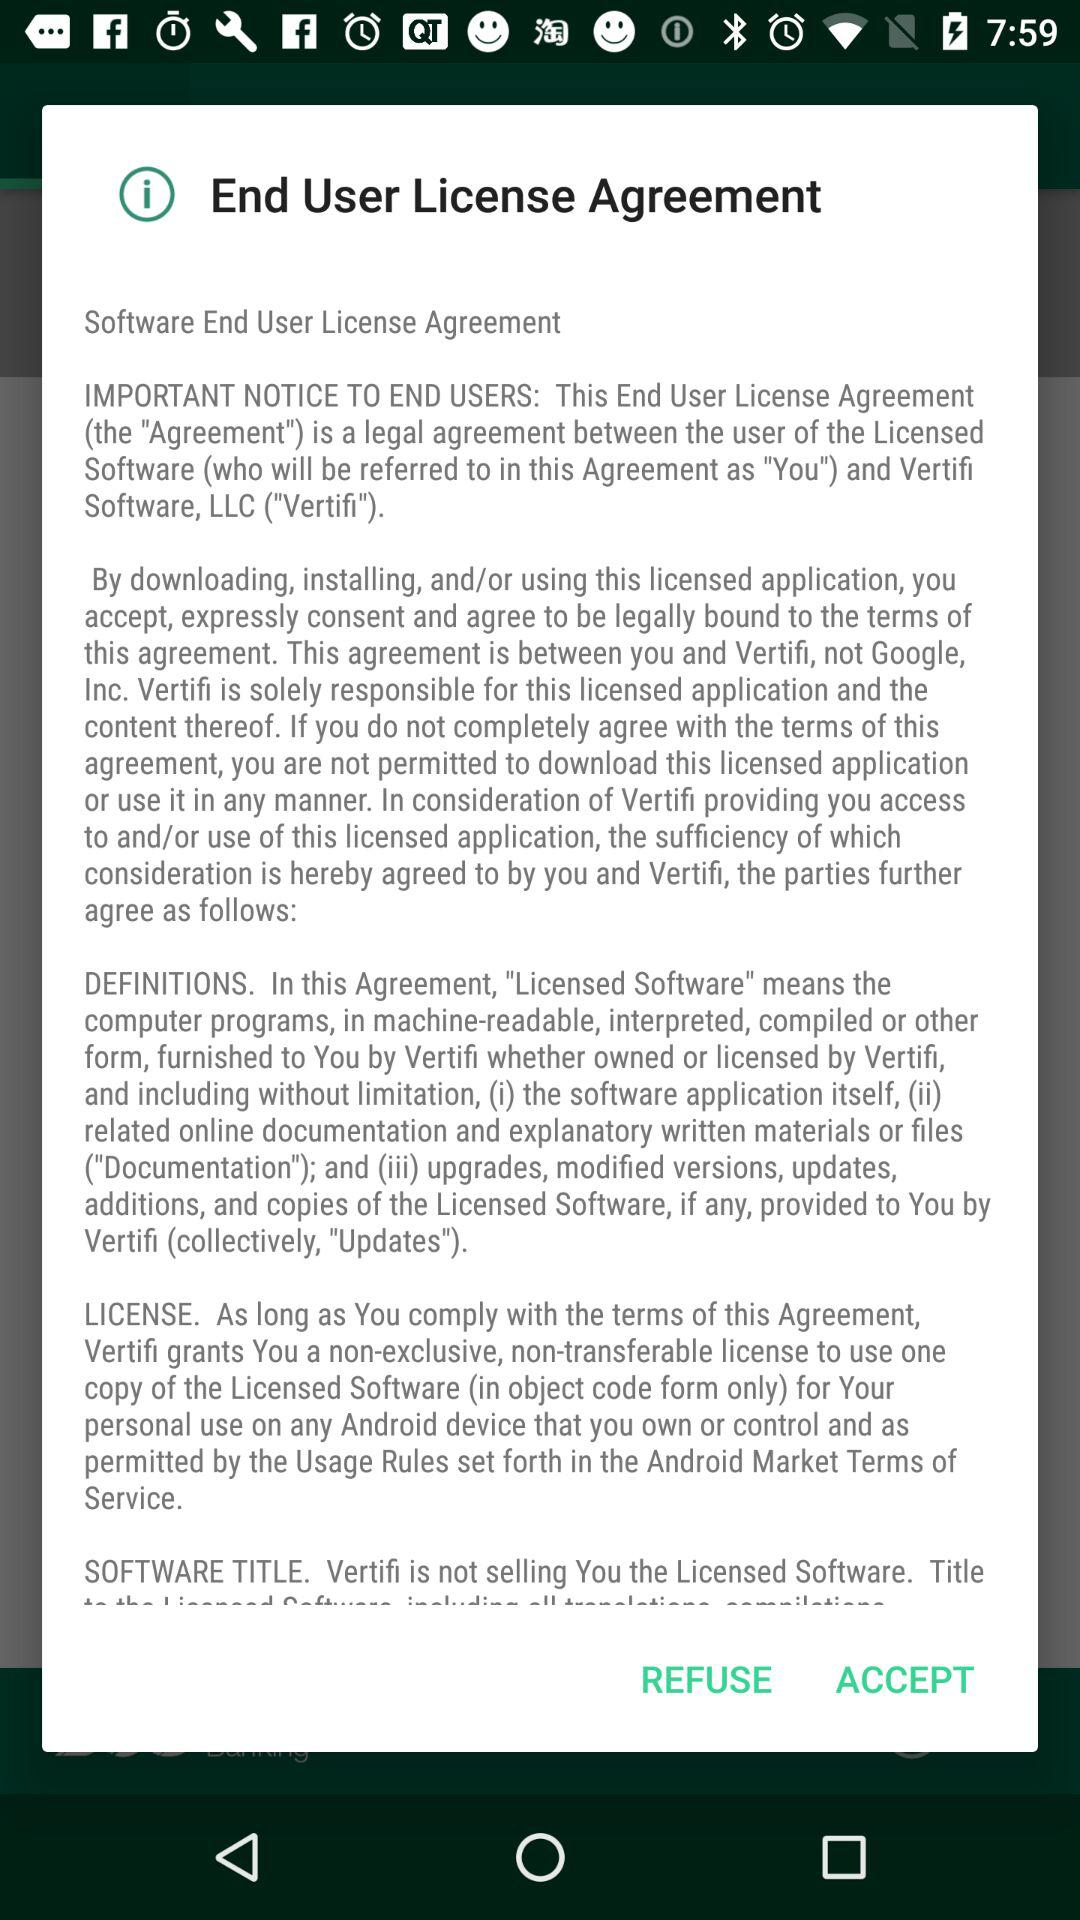What is the End User License Agreement? The End User License Agreement is a legal agreement between the user of the Licensed Software (who will be referred to in this Agreement as "You") and Vertifi Software, LLC ("Vertifi"). 